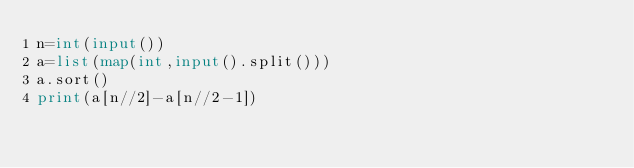Convert code to text. <code><loc_0><loc_0><loc_500><loc_500><_Python_>n=int(input())
a=list(map(int,input().split()))
a.sort()
print(a[n//2]-a[n//2-1])</code> 